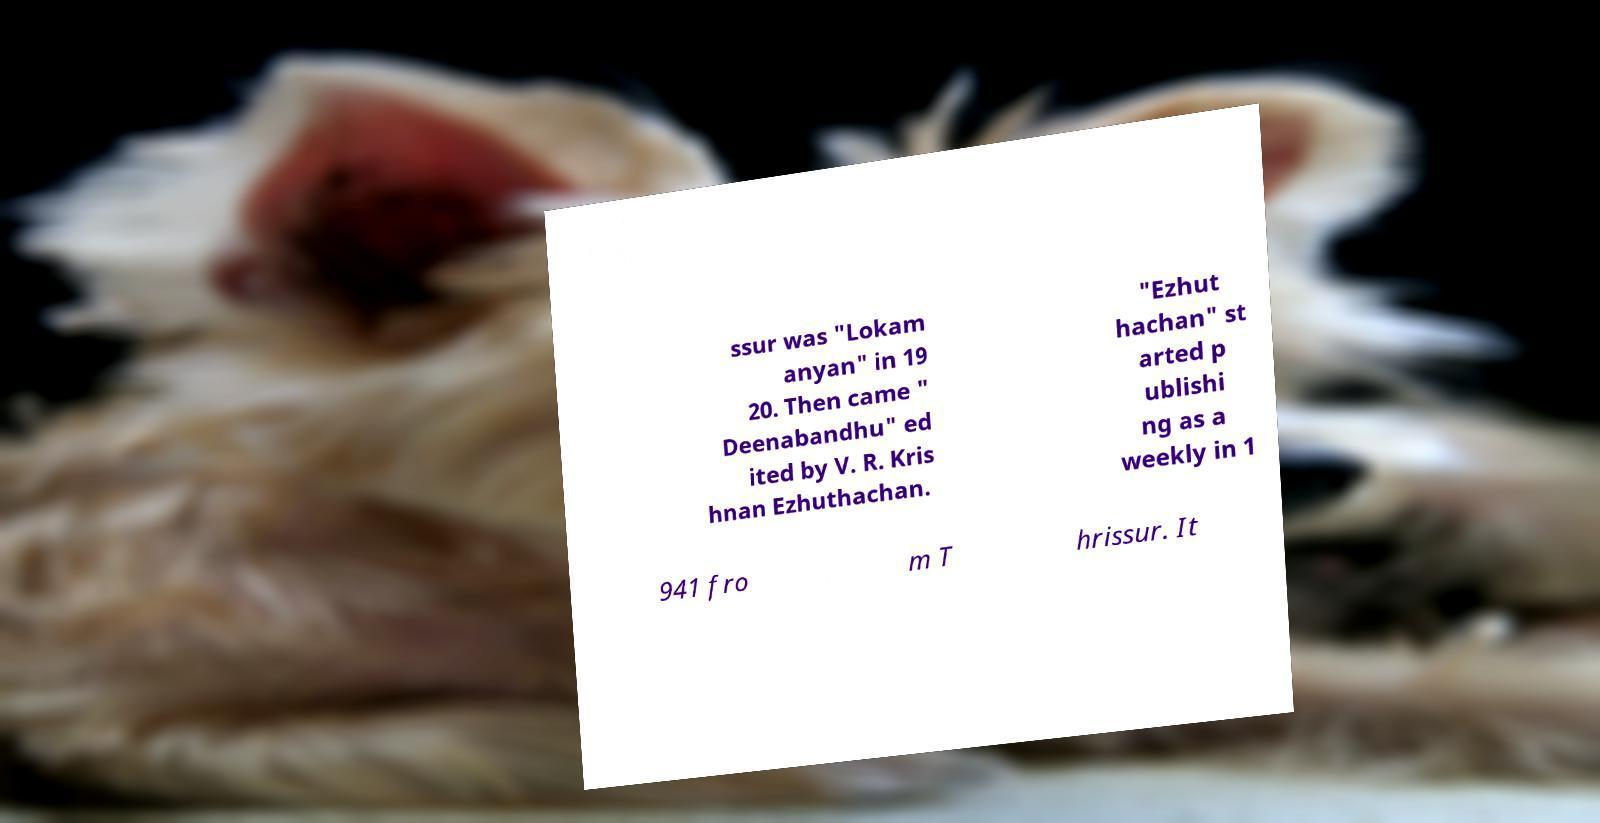There's text embedded in this image that I need extracted. Can you transcribe it verbatim? ssur was "Lokam anyan" in 19 20. Then came " Deenabandhu" ed ited by V. R. Kris hnan Ezhuthachan. "Ezhut hachan" st arted p ublishi ng as a weekly in 1 941 fro m T hrissur. It 